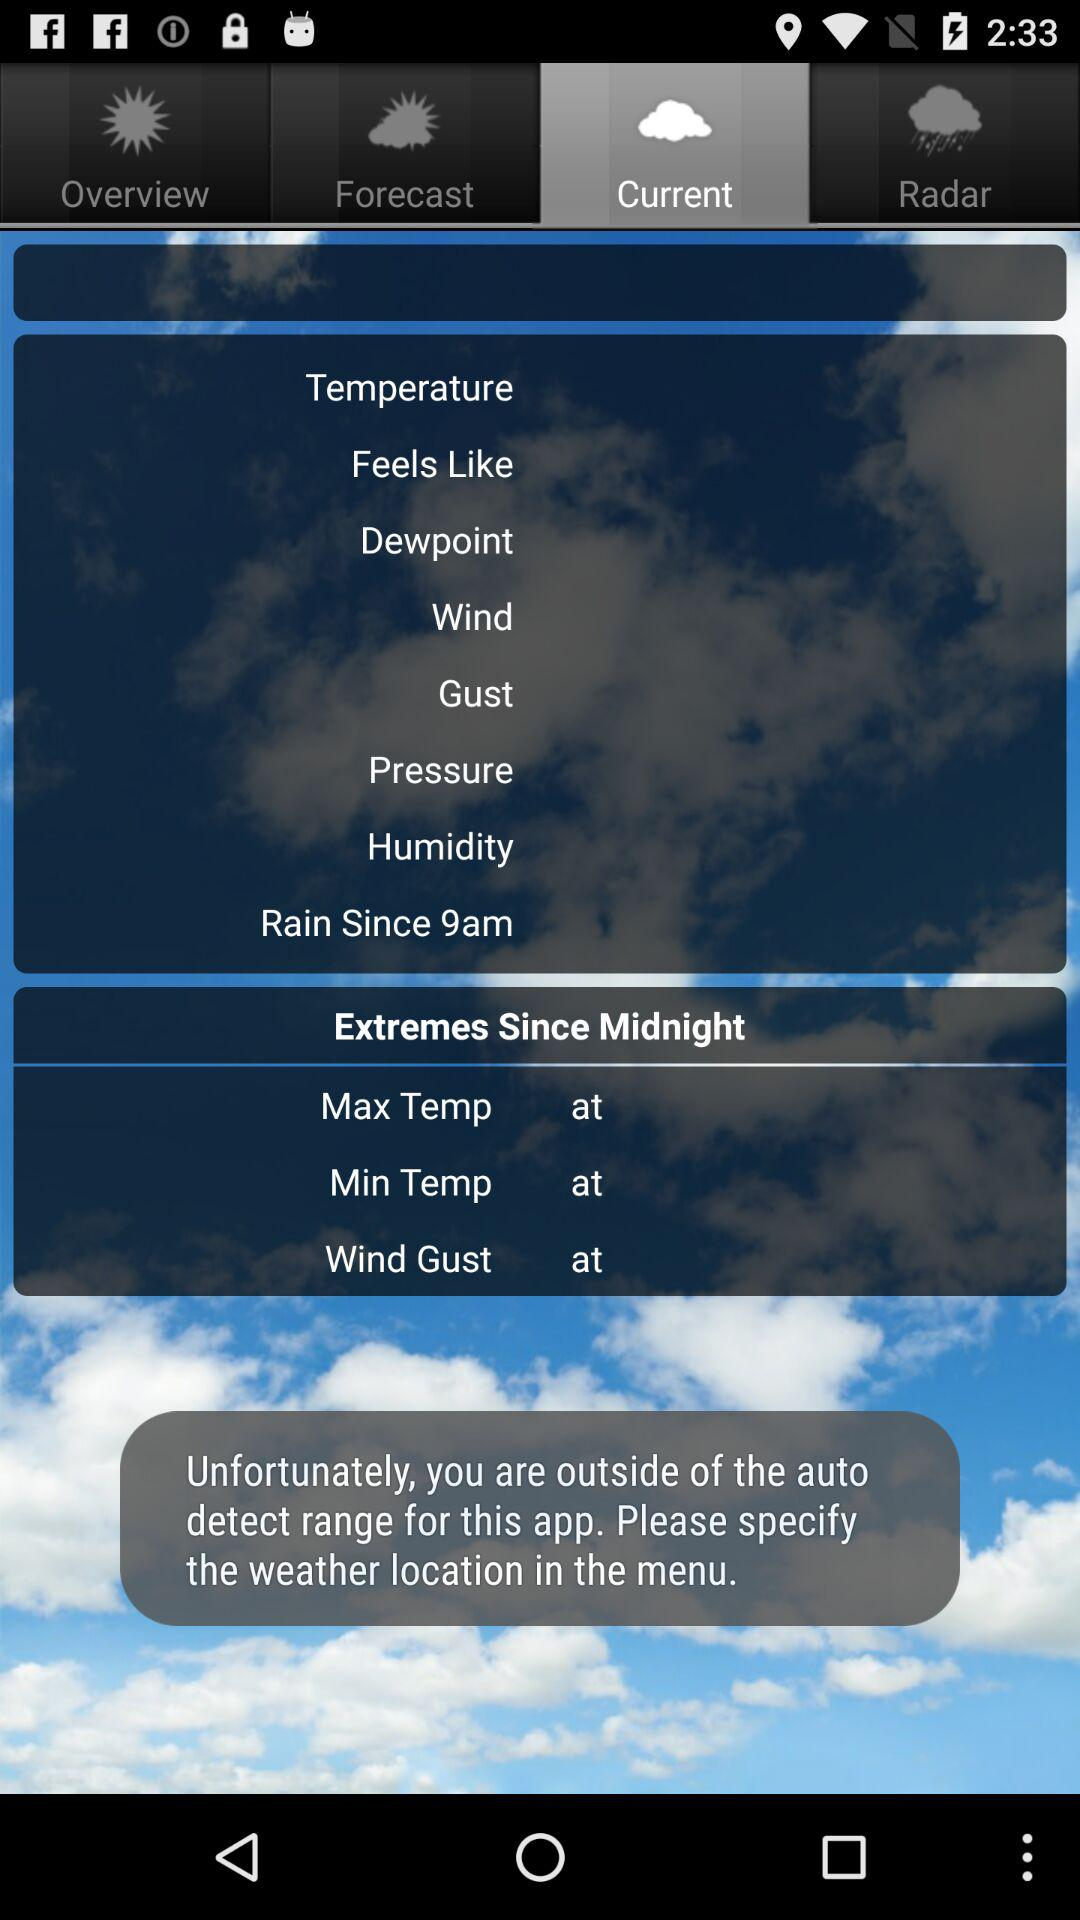Which tab has been selected? The selected tab is "Current". 